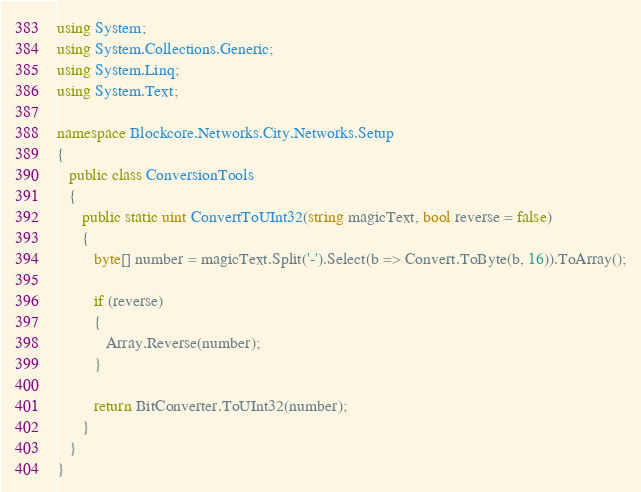<code> <loc_0><loc_0><loc_500><loc_500><_C#_>using System;
using System.Collections.Generic;
using System.Linq;
using System.Text;

namespace Blockcore.Networks.City.Networks.Setup
{
   public class ConversionTools
   {
      public static uint ConvertToUInt32(string magicText, bool reverse = false)
      {
         byte[] number = magicText.Split('-').Select(b => Convert.ToByte(b, 16)).ToArray();

         if (reverse)
         {
            Array.Reverse(number);
         }

         return BitConverter.ToUInt32(number);
      }
   }
}
</code> 